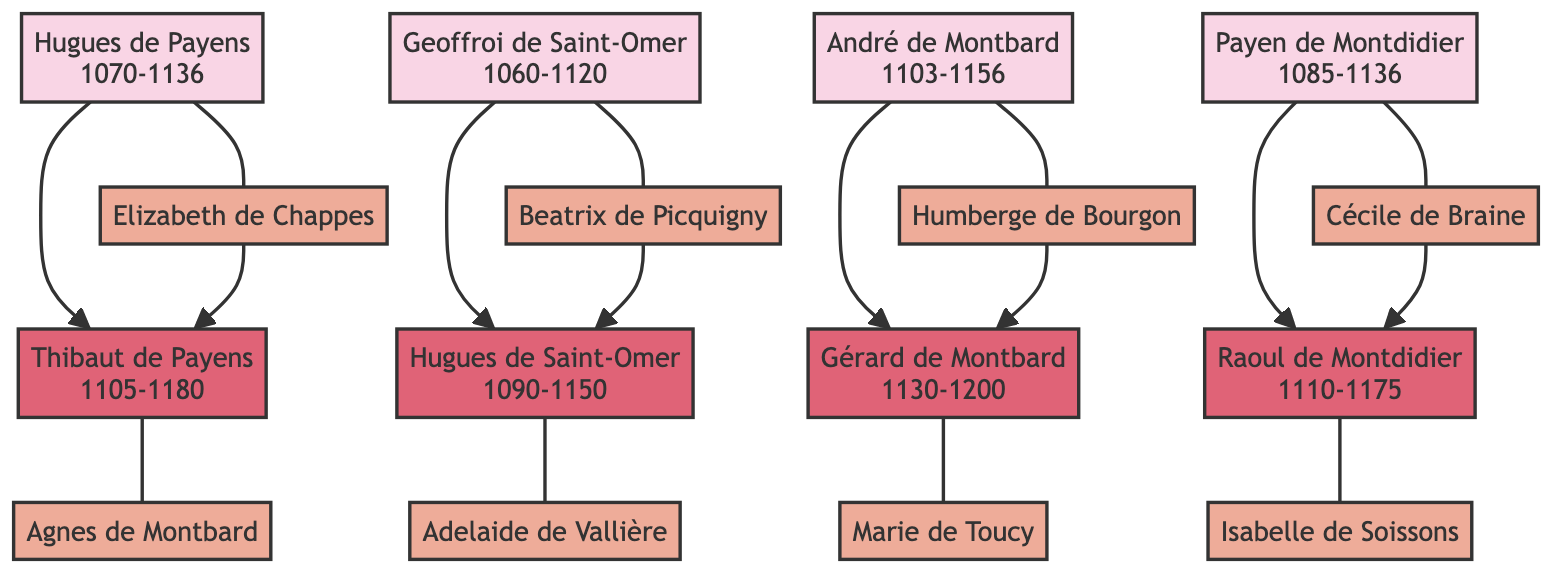What is the name of Hugues de Payens' spouse? The diagram shows Hugues de Payens connected to Elizabeth de Chappes, indicating that she is his spouse.
Answer: Elizabeth de Chappes How many children did Payen de Montdidier have? The diagram displays Payen de Montdidier with one direct connection to his child, Raoul de Montdidier, indicating he had one child.
Answer: 1 Who was Gérard de Montbard's father? Gérard de Montbard is connected to André de Montbard in the diagram, showing that André is his father.
Answer: André de Montbard Which year was Hugues de Saint-Omer born? By examining the node for Hugues de Saint-Omer, the diagram specifies that he was born in 1090.
Answer: 1090 What is the relationship between Thibaut de Payens and Hugues de Payens? Thibaut de Payens is directly connected to Hugues de Payens as his child, which indicates a parent-child relationship.
Answer: Child What is the birth year of Raoul de Montdidier's spouse? The diagram shows Raoul de Montdidier married to Isabelle de Soissons. To answer the question, we need to check Isabelle’s information, which is not present; thus, the exact year cannot be determined.
Answer: Not available How many founding members of the Knights Templar are shown in the diagram? The diagram depicts four founding members: Hugues de Payens, Geoffroi de Saint-Omer, André de Montbard, and Payen de Montdidier, which totals four members.
Answer: 4 Who is the spouse of André de Montbard? Looking at the node for André de Montbard, it shows that his spouse is Humberge de Bourgon.
Answer: Humberge de Bourgon What is the death year of Raoul de Montdidier? The diagram indicates that Raoul de Montdidier died in 1175, which is directly stated in his node.
Answer: 1175 Which member has the longest lifespan? To determine this, we need to compare the birth and death years of all members. Hugues de Payens lived from 1070 to 1136, a total of 66 years. The others all lived less than this duration. Thus, Hugues de Payens has the longest lifespan.
Answer: Hugues de Payens 